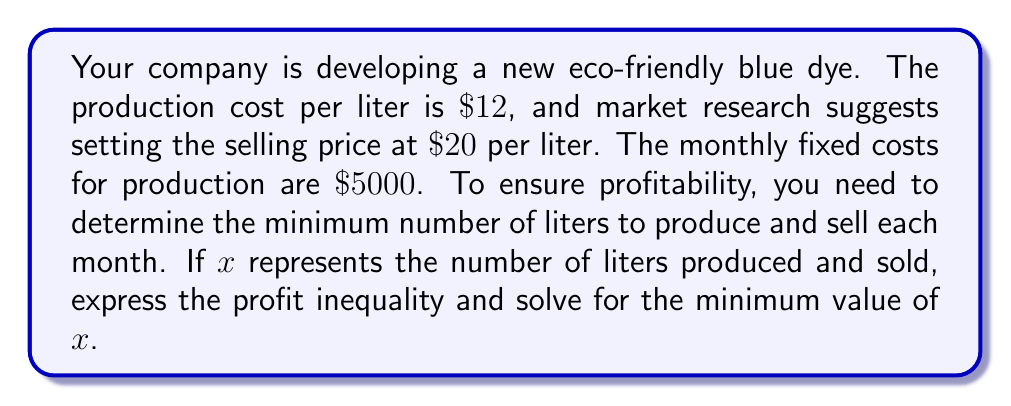Provide a solution to this math problem. Let's approach this step-by-step:

1) First, let's define our variables:
   $x$ = number of liters produced and sold
   Revenue per liter = $\$20$
   Cost per liter = $\$12$
   Fixed costs = $\$5000$

2) To be profitable, revenue must exceed total costs:
   Revenue > Total Costs

3) Let's express this as an inequality:
   $20x > 12x + 5000$

4) Simplify the left side of the inequality:
   $20x - 12x > 5000$
   $8x > 5000$

5) Divide both sides by 8:
   $x > \frac{5000}{8} = 625$

6) Since $x$ represents the number of liters, it must be a whole number. Therefore, we need to round up to the nearest integer.

7) The minimum number of liters to produce and sell for profitability is 626.
Answer: 626 liters 